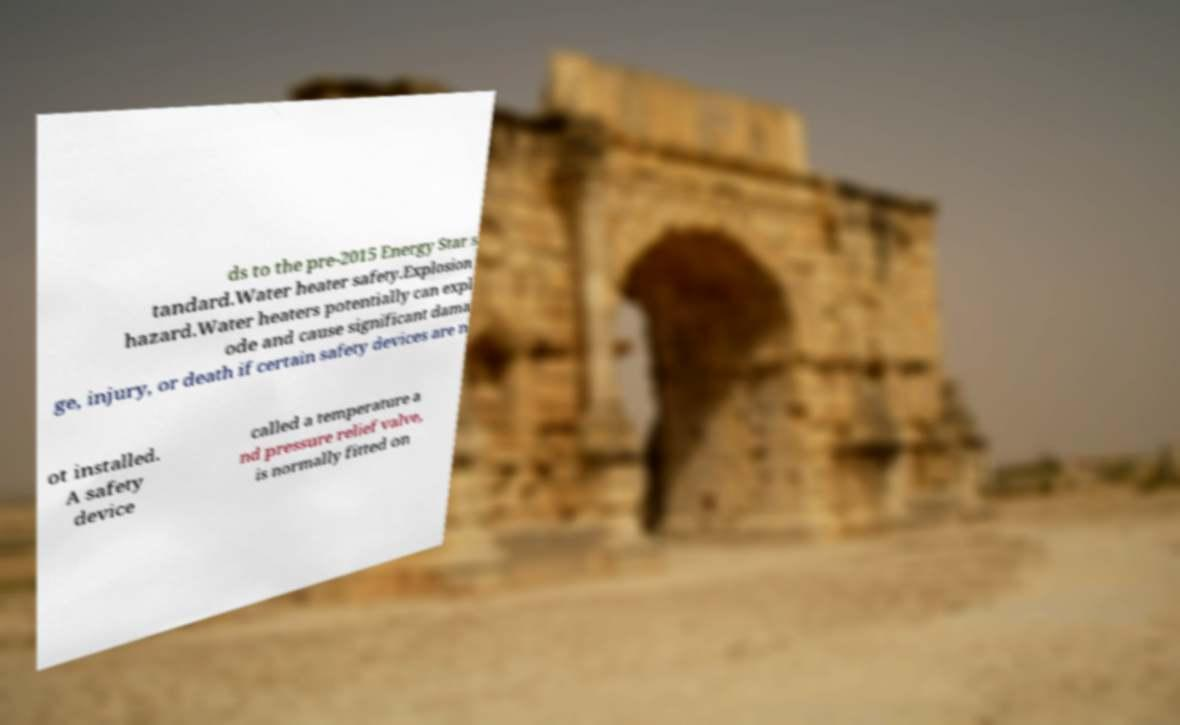For documentation purposes, I need the text within this image transcribed. Could you provide that? ds to the pre-2015 Energy Star s tandard.Water heater safety.Explosion hazard.Water heaters potentially can expl ode and cause significant dama ge, injury, or death if certain safety devices are n ot installed. A safety device called a temperature a nd pressure relief valve, is normally fitted on 